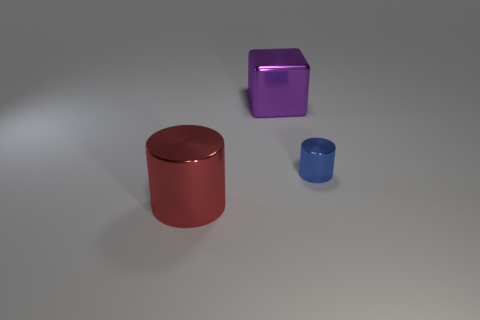Add 3 big things. How many objects exist? 6 Subtract all blocks. How many objects are left? 2 Add 3 tiny blue metal things. How many tiny blue metal things are left? 4 Add 2 big red metallic objects. How many big red metallic objects exist? 3 Subtract 0 gray spheres. How many objects are left? 3 Subtract all blue shiny cylinders. Subtract all small metallic cylinders. How many objects are left? 1 